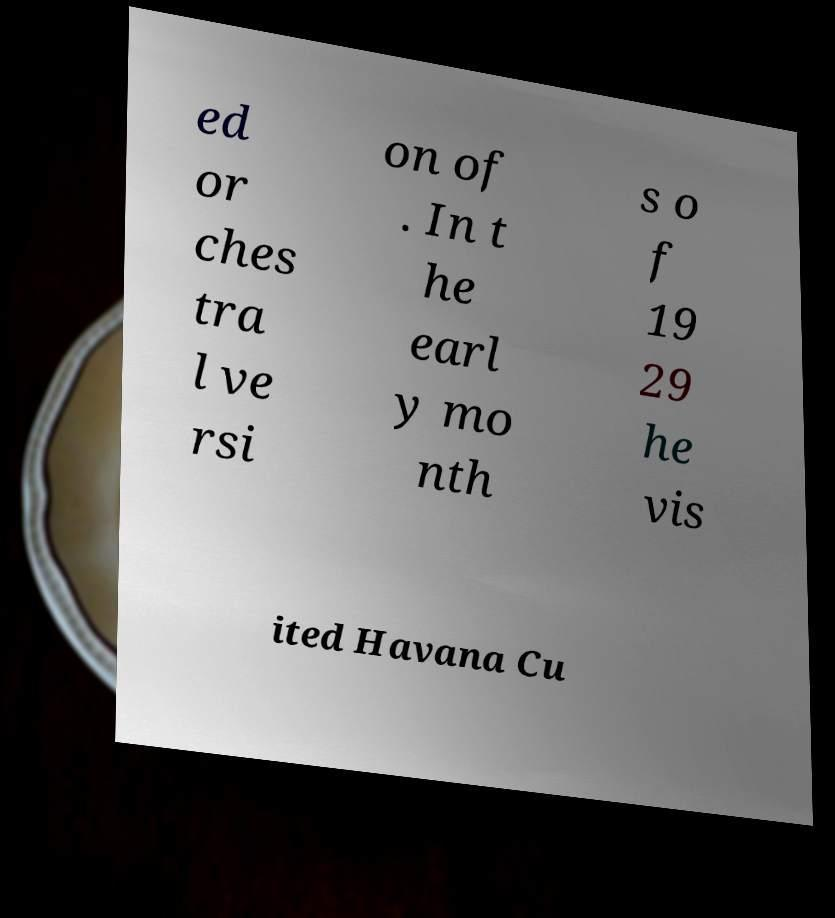I need the written content from this picture converted into text. Can you do that? ed or ches tra l ve rsi on of . In t he earl y mo nth s o f 19 29 he vis ited Havana Cu 